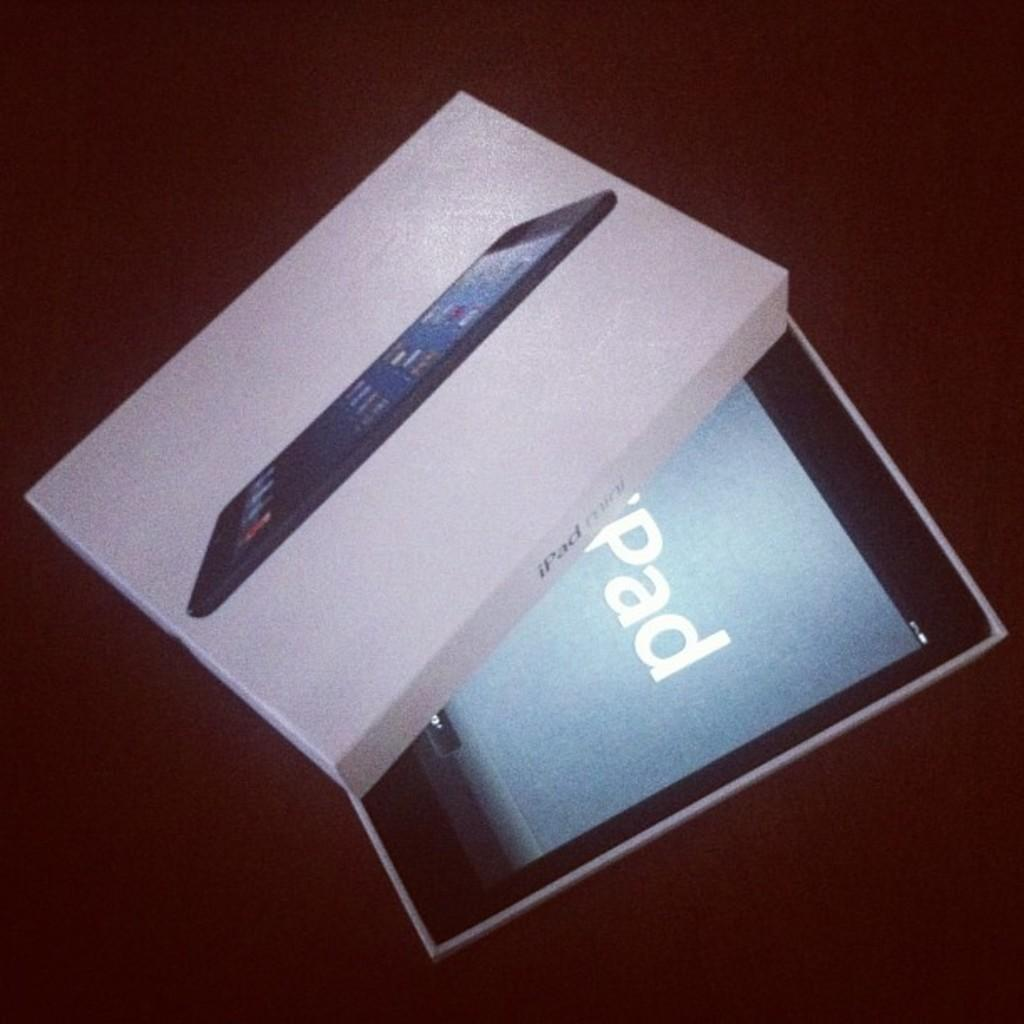What object is present in the image that resembles a container? There is a cardboard box in the image. What is depicted on the cardboard box? The cardboard box has a picture of an iPad on it. What electronic device can be seen in the image? There is an iPad with a display in the image. What color is the background of the image? The background of the image appears to be brown in color. What type of cheese is being used to solve the riddle in the image? There is no cheese or riddle present in the image. 